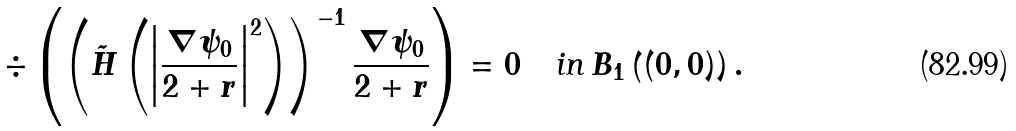Convert formula to latex. <formula><loc_0><loc_0><loc_500><loc_500>\div \left ( \left ( \tilde { H } \left ( \left | \frac { \nabla \psi _ { 0 } } { 2 + r } \right | ^ { 2 } \right ) \right ) ^ { - 1 } \frac { \nabla \psi _ { 0 } } { 2 + r } \right ) = 0 \quad \text {in} \, B _ { 1 } \left ( ( 0 , 0 ) \right ) .</formula> 